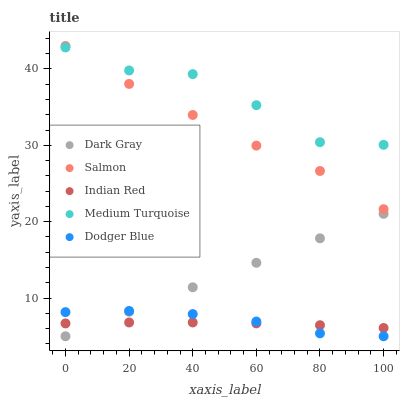Does Indian Red have the minimum area under the curve?
Answer yes or no. Yes. Does Medium Turquoise have the maximum area under the curve?
Answer yes or no. Yes. Does Dodger Blue have the minimum area under the curve?
Answer yes or no. No. Does Dodger Blue have the maximum area under the curve?
Answer yes or no. No. Is Dark Gray the smoothest?
Answer yes or no. Yes. Is Medium Turquoise the roughest?
Answer yes or no. Yes. Is Dodger Blue the smoothest?
Answer yes or no. No. Is Dodger Blue the roughest?
Answer yes or no. No. Does Dark Gray have the lowest value?
Answer yes or no. Yes. Does Salmon have the lowest value?
Answer yes or no. No. Does Salmon have the highest value?
Answer yes or no. Yes. Does Dodger Blue have the highest value?
Answer yes or no. No. Is Dark Gray less than Medium Turquoise?
Answer yes or no. Yes. Is Salmon greater than Dodger Blue?
Answer yes or no. Yes. Does Indian Red intersect Dark Gray?
Answer yes or no. Yes. Is Indian Red less than Dark Gray?
Answer yes or no. No. Is Indian Red greater than Dark Gray?
Answer yes or no. No. Does Dark Gray intersect Medium Turquoise?
Answer yes or no. No. 